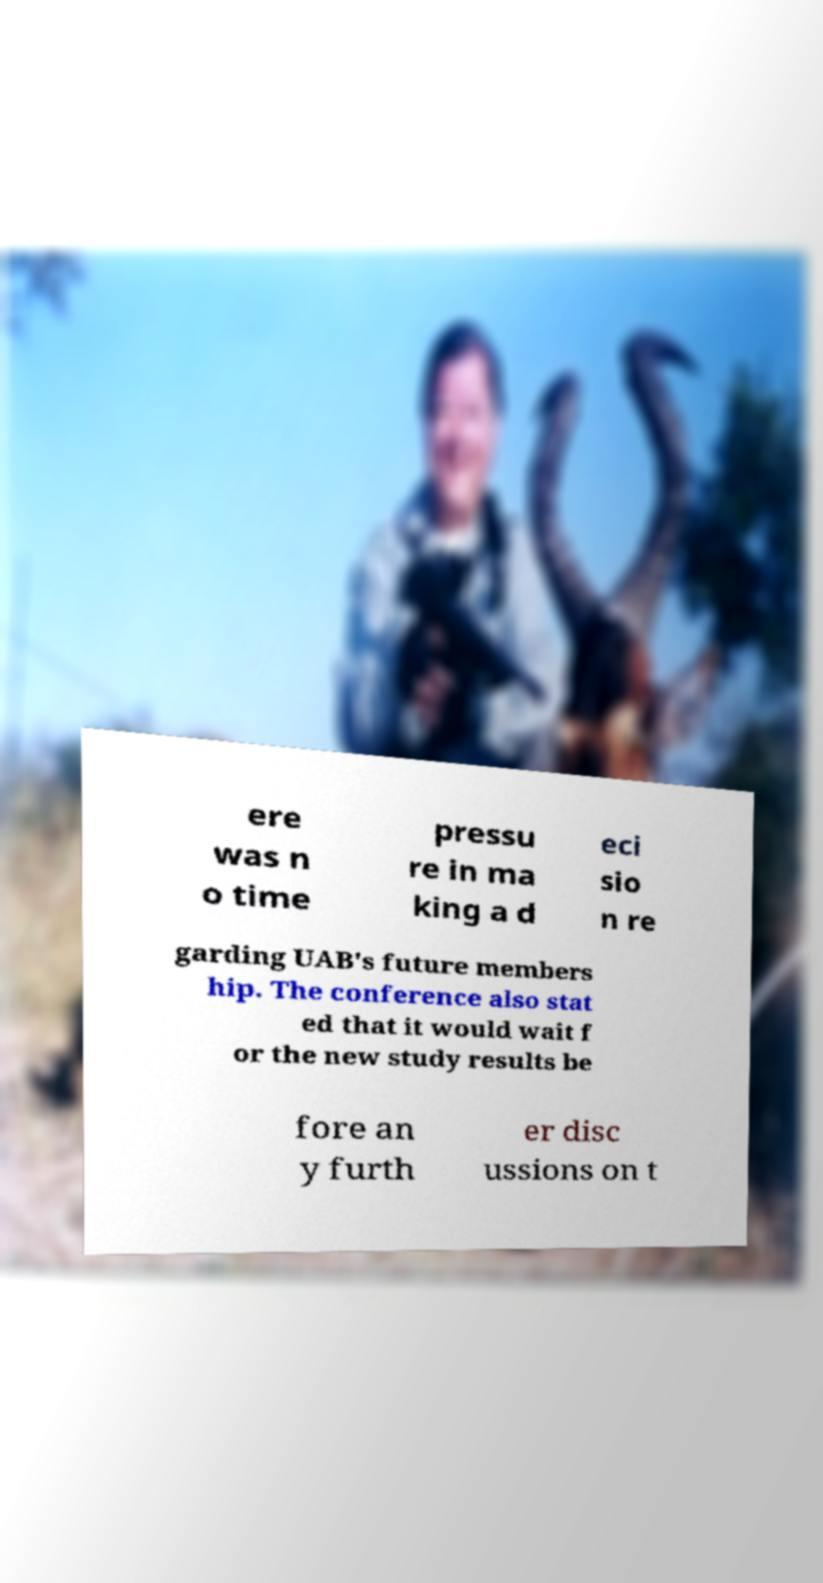Could you assist in decoding the text presented in this image and type it out clearly? ere was n o time pressu re in ma king a d eci sio n re garding UAB's future members hip. The conference also stat ed that it would wait f or the new study results be fore an y furth er disc ussions on t 